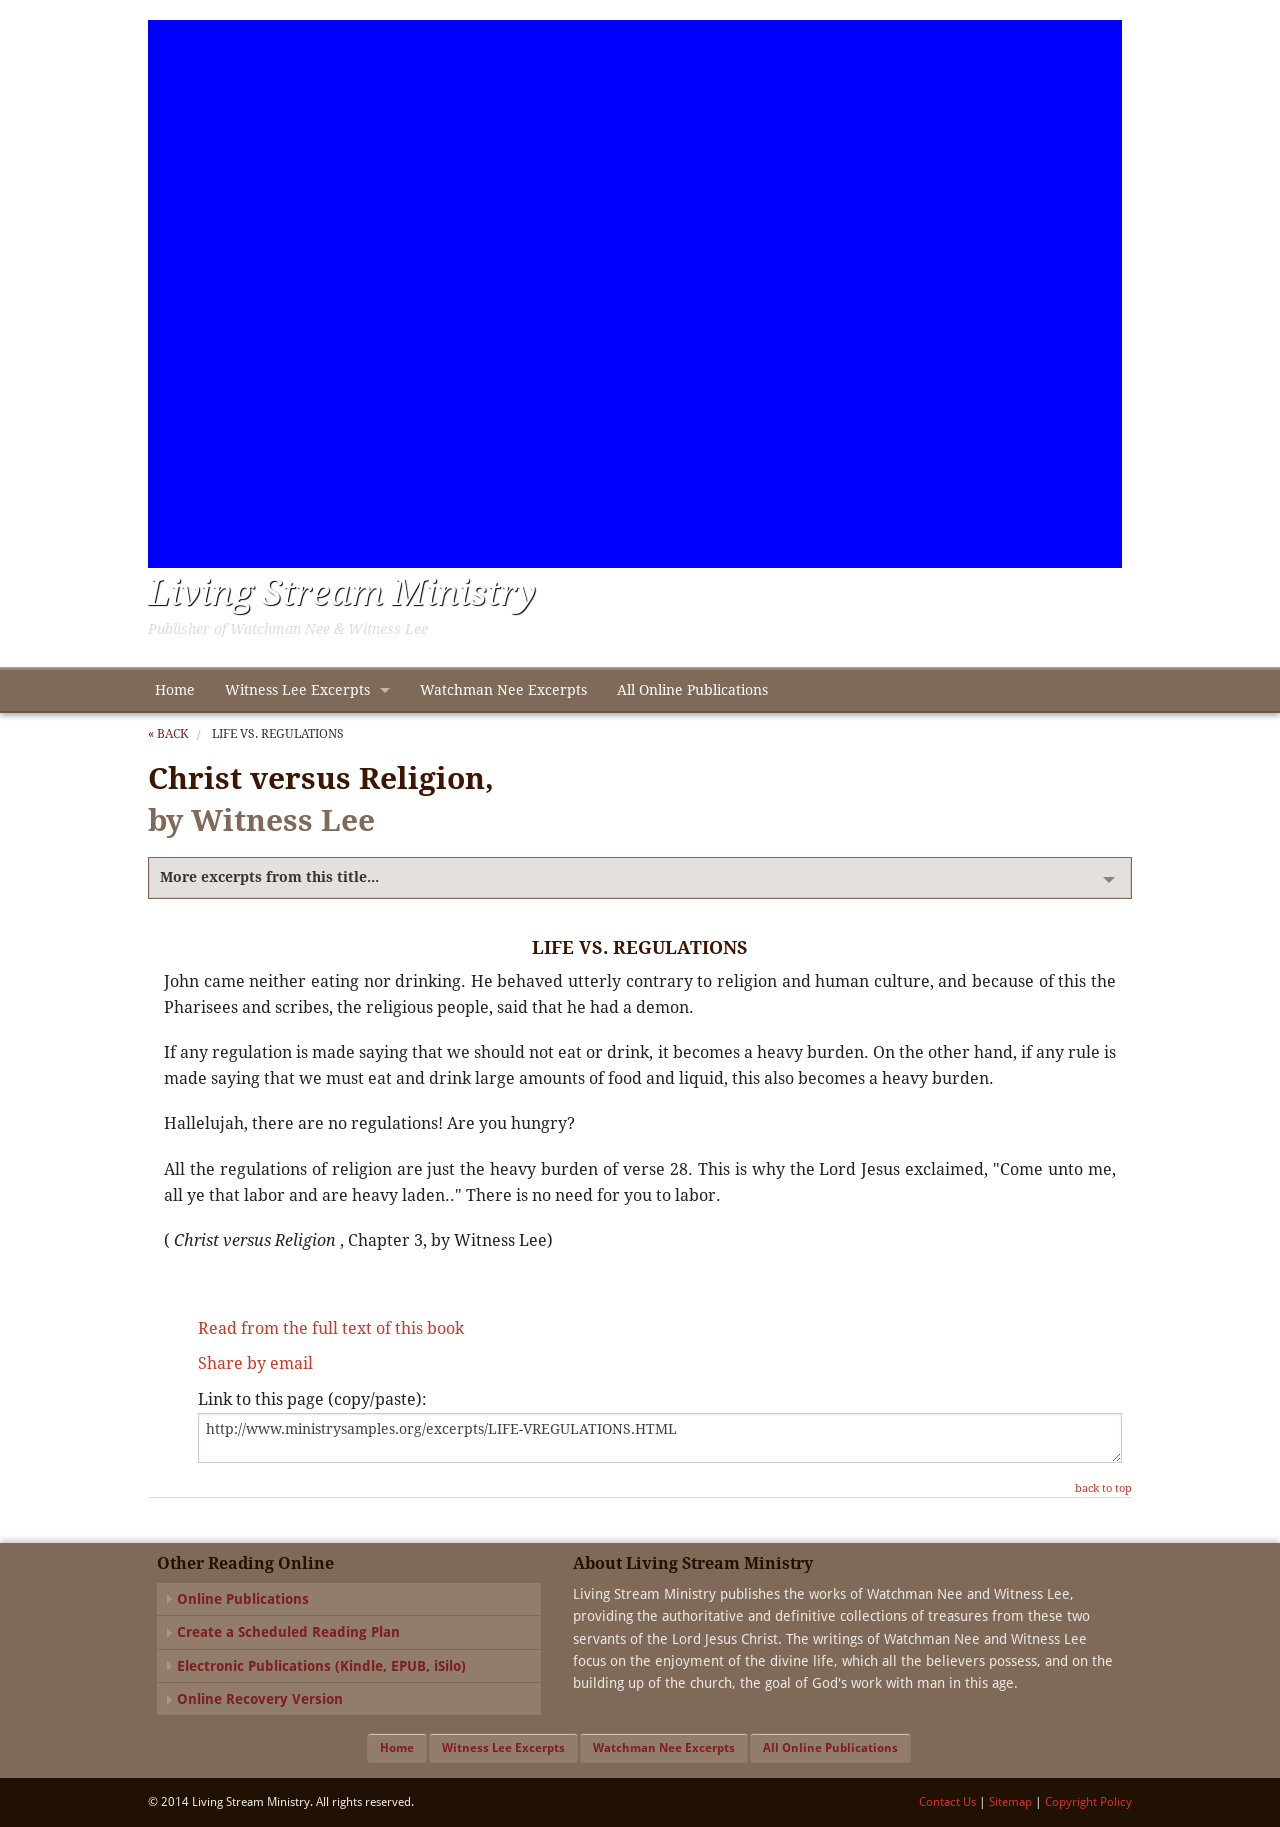Could you explain the title 'Christ versus Religion' as depicted in this image? The title 'Christ versus Religion' implies a fundamental discussion about the differences between following Christ as a person and the essence of his teachings versus adhering to organized religion or doctrine that may potentially lead to legalistic practice. The text challenges the reader to consider the spiritual implications of religious practices that may divert from the original teachings of Christ. How does the author suggest one should deal with religious regulations? The author, Witness Lee, suggests that rather than adhering to strict religious regulations, believers should find liberation in Christ who offers relief from such burdens. He emphasizes that Jesus invites those burdened by man-made rules to come to him and find rest, highlighting a personal relationship with Christ over ritual compliance. 